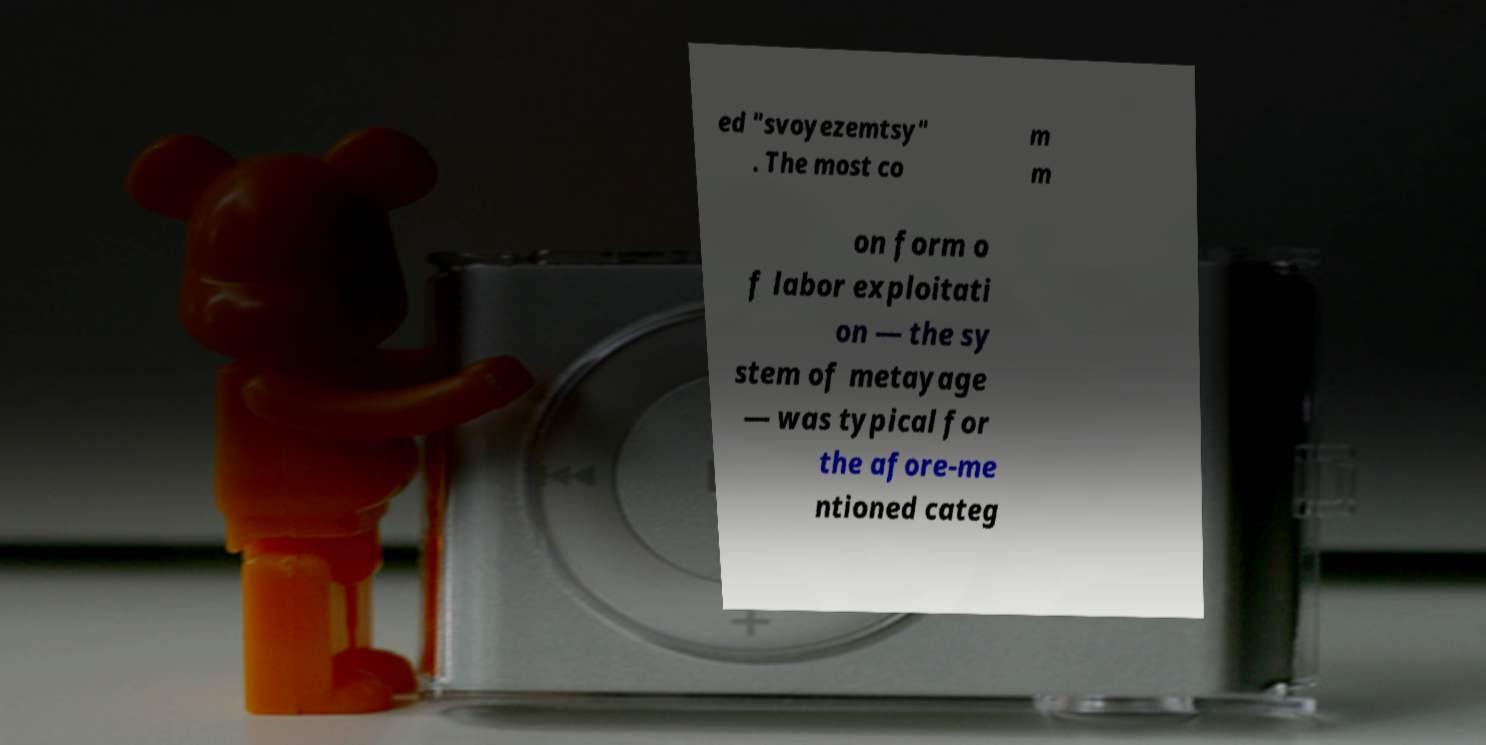Could you assist in decoding the text presented in this image and type it out clearly? ed "svoyezemtsy" . The most co m m on form o f labor exploitati on — the sy stem of metayage — was typical for the afore-me ntioned categ 